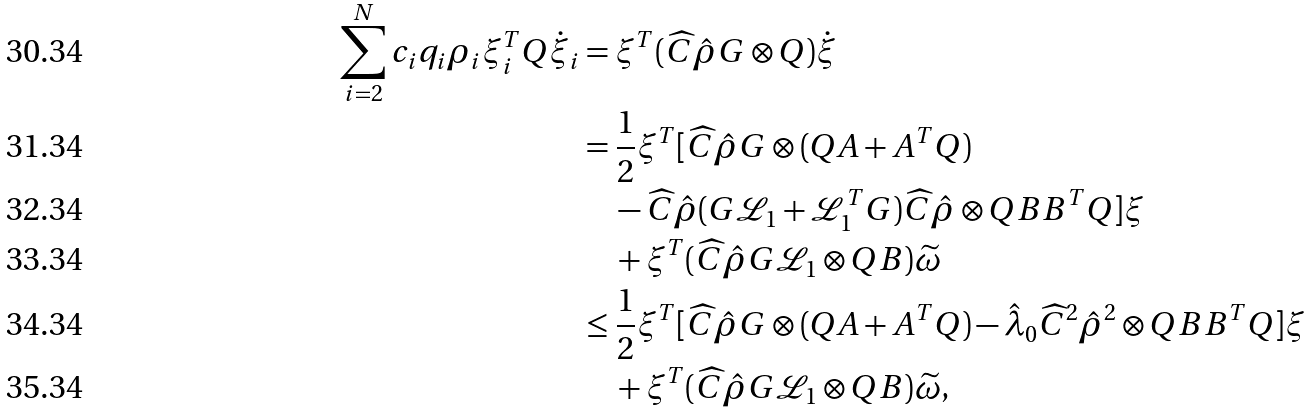Convert formula to latex. <formula><loc_0><loc_0><loc_500><loc_500>\sum _ { i = 2 } ^ { N } c _ { i } q _ { i } \rho _ { i } \xi _ { i } ^ { T } Q \dot { \xi } _ { i } & = \xi ^ { T } ( \widehat { C } \hat { \rho } G \otimes Q ) \dot { \xi } \\ & = \frac { 1 } { 2 } \xi ^ { T } [ \widehat { C } \hat { \rho } G \otimes ( Q A + A ^ { T } Q ) \\ & \quad - \widehat { C } \hat { \rho } ( G \mathcal { L } _ { 1 } + \mathcal { L } _ { 1 } ^ { T } G ) \widehat { C } \hat { \rho } \otimes Q B B ^ { T } Q ] \xi \\ & \quad + \xi ^ { T } ( \widehat { C } \hat { \rho } G \mathcal { L } _ { 1 } \otimes Q B ) \widetilde { \omega } \\ & \leq \frac { 1 } { 2 } \xi ^ { T } [ \widehat { C } \hat { \rho } G \otimes ( Q A + A ^ { T } Q ) - \hat { \lambda } _ { 0 } \widehat { C } ^ { 2 } \hat { \rho } ^ { 2 } \otimes Q B B ^ { T } Q ] \xi \\ & \quad + \xi ^ { T } ( \widehat { C } \hat { \rho } G \mathcal { L } _ { 1 } \otimes Q B ) \widetilde { \omega } ,</formula> 